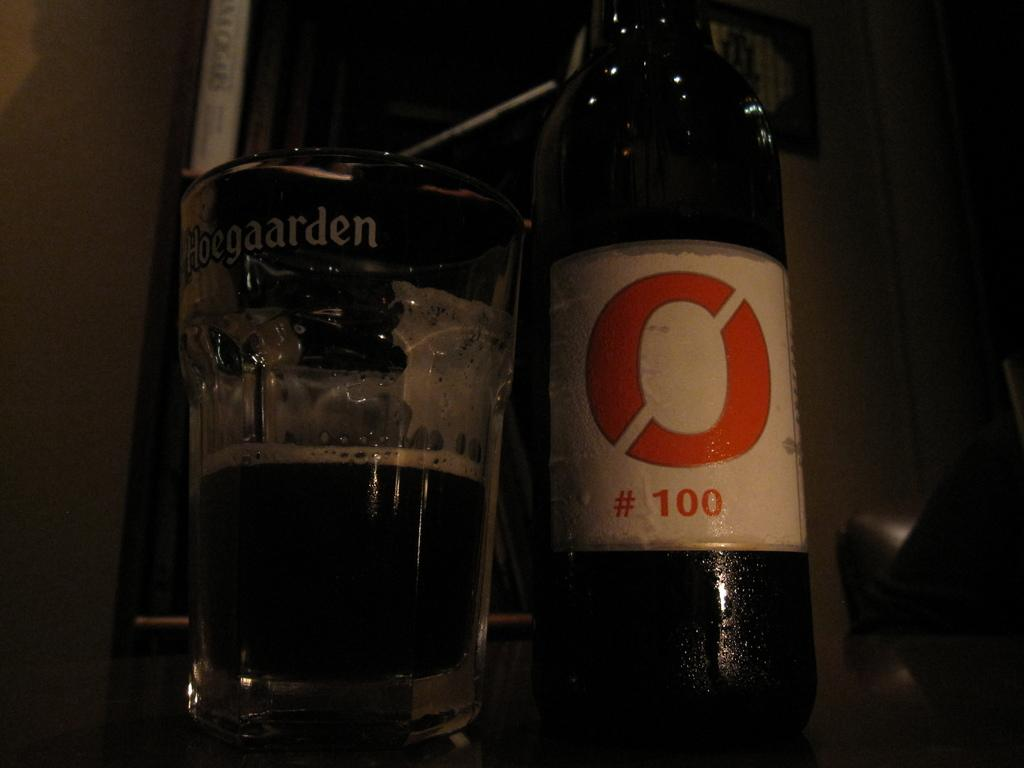<image>
Relay a brief, clear account of the picture shown. A glass that says Hoegaarden next to a bottle of beer. 